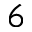Convert formula to latex. <formula><loc_0><loc_0><loc_500><loc_500>_ { 6 }</formula> 